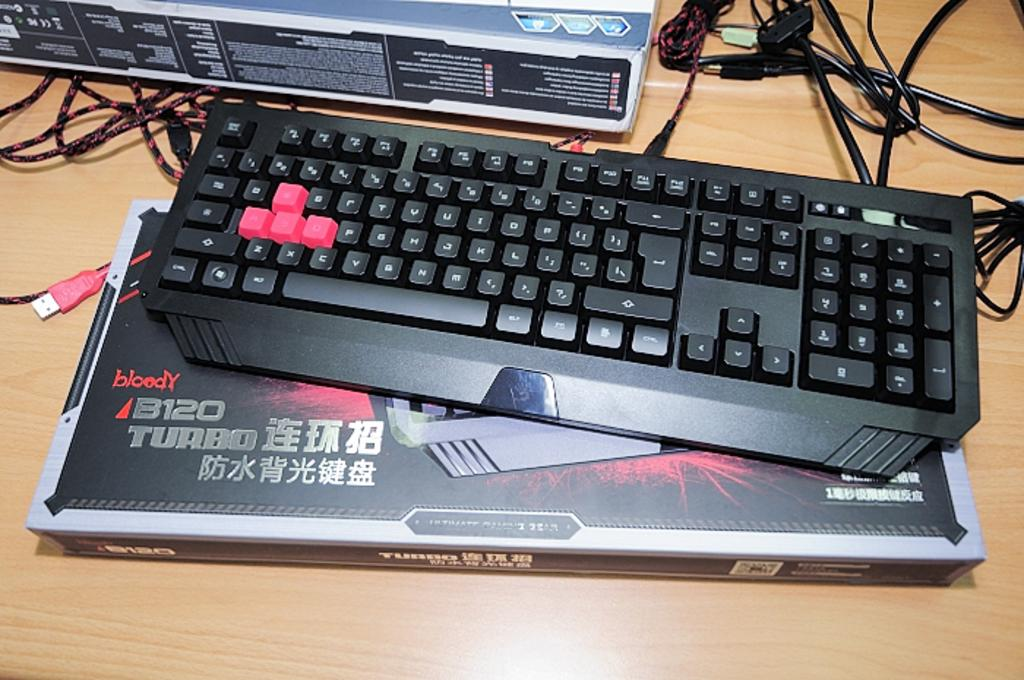<image>
Share a concise interpretation of the image provided. A black and red keyboard is a B120 Turbo model. 